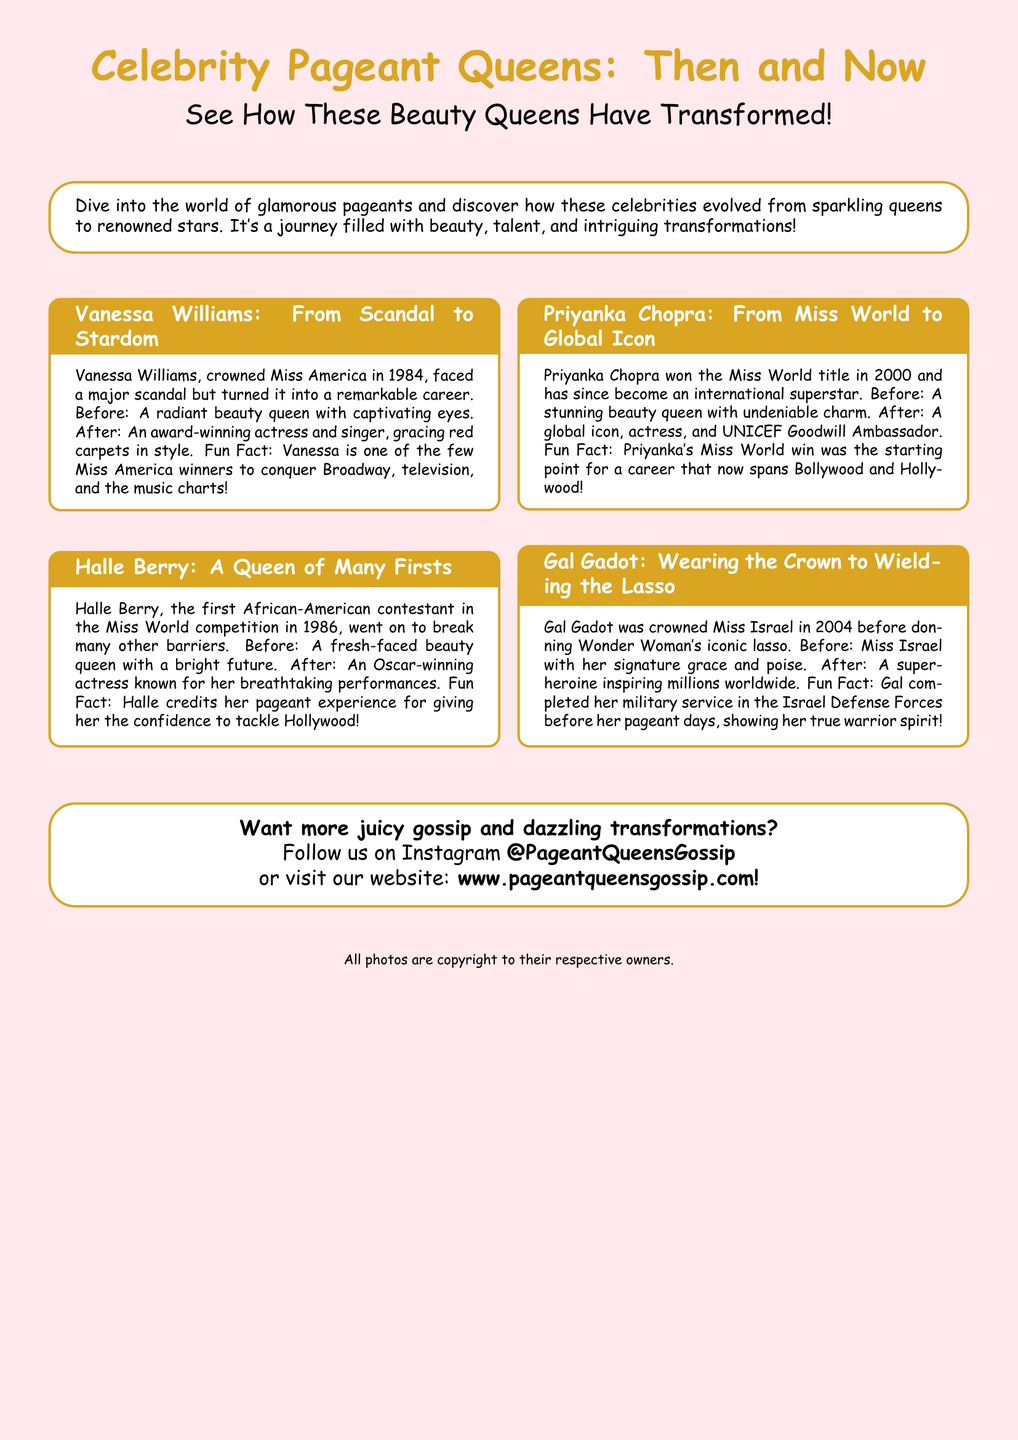What year was Vanessa Williams crowned Miss America? The document states that Vanessa Williams was crowned Miss America in 1984.
Answer: 1984 What is the title that Priyanka Chopra won in 2000? The document mentions that Priyanka Chopra won the Miss World title in 2000.
Answer: Miss World Who is the first African-American contestant in the Miss World competition? According to the document, Halle Berry was the first African-American contestant in the Miss World competition.
Answer: Halle Berry What commonality exists between all the celebrities mentioned? The document highlights that each celebrity evolved from a beauty queen to a well-known figure in their own right.
Answer: Beauty Queens What did Gal Gadot complete before her pageant days? The document mentions that Gal Gadot completed her military service in the Israel Defense Forces.
Answer: Military service What is the Instagram handle mentioned for further updates? The document provides the Instagram handle for updates as @PageantQueensGossip.
Answer: @PageantQueensGossip Which celebrity is known for playing Wonder Woman? The document states that Gal Gadot is known for playing Wonder Woman.
Answer: Gal Gadot What is one of the fun facts about Halle Berry? The document states that Halle credits her pageant experience for her confidence in Hollywood.
Answer: Pageant experience confidence 